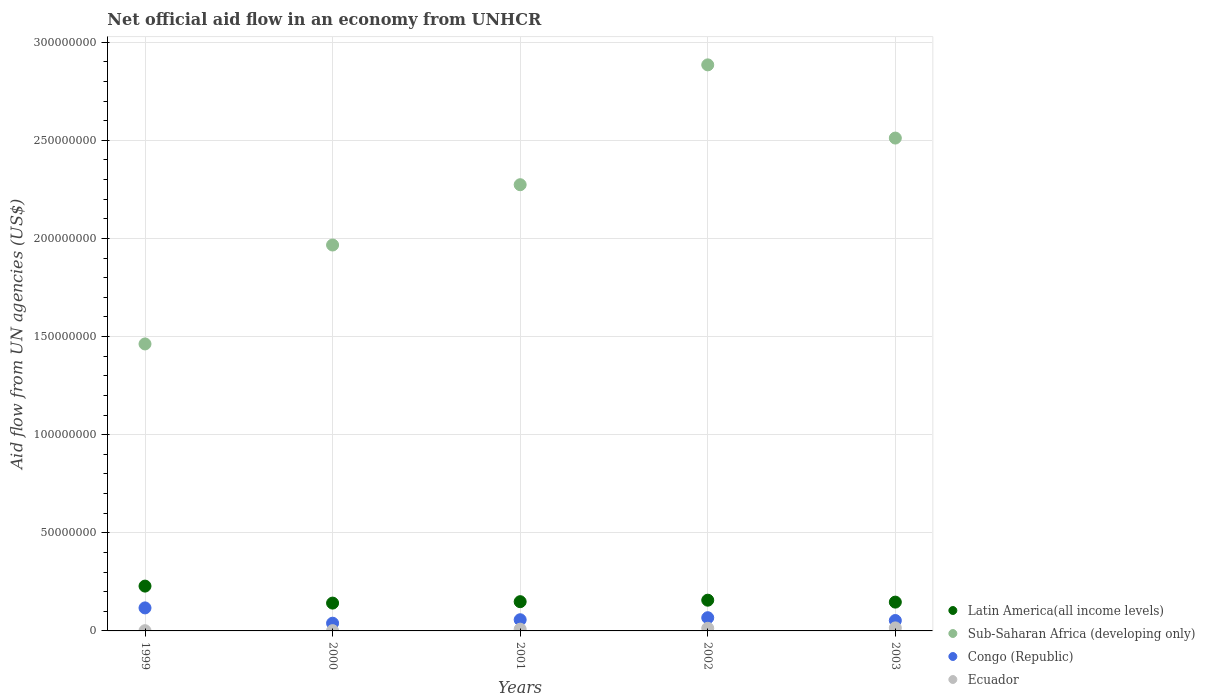How many different coloured dotlines are there?
Your answer should be compact. 4. Is the number of dotlines equal to the number of legend labels?
Keep it short and to the point. Yes. What is the net official aid flow in Congo (Republic) in 2000?
Offer a terse response. 3.93e+06. Across all years, what is the maximum net official aid flow in Latin America(all income levels)?
Offer a terse response. 2.28e+07. Across all years, what is the minimum net official aid flow in Sub-Saharan Africa (developing only)?
Provide a short and direct response. 1.46e+08. In which year was the net official aid flow in Latin America(all income levels) maximum?
Keep it short and to the point. 1999. In which year was the net official aid flow in Sub-Saharan Africa (developing only) minimum?
Make the answer very short. 1999. What is the total net official aid flow in Latin America(all income levels) in the graph?
Ensure brevity in your answer.  8.23e+07. What is the difference between the net official aid flow in Sub-Saharan Africa (developing only) in 1999 and that in 2000?
Provide a succinct answer. -5.04e+07. What is the difference between the net official aid flow in Latin America(all income levels) in 1999 and the net official aid flow in Sub-Saharan Africa (developing only) in 2001?
Your answer should be very brief. -2.05e+08. What is the average net official aid flow in Latin America(all income levels) per year?
Offer a very short reply. 1.65e+07. In the year 2003, what is the difference between the net official aid flow in Congo (Republic) and net official aid flow in Latin America(all income levels)?
Provide a succinct answer. -9.38e+06. What is the ratio of the net official aid flow in Ecuador in 1999 to that in 2000?
Ensure brevity in your answer.  0.86. Is the difference between the net official aid flow in Congo (Republic) in 2002 and 2003 greater than the difference between the net official aid flow in Latin America(all income levels) in 2002 and 2003?
Ensure brevity in your answer.  Yes. What is the difference between the highest and the second highest net official aid flow in Latin America(all income levels)?
Provide a short and direct response. 7.18e+06. What is the difference between the highest and the lowest net official aid flow in Sub-Saharan Africa (developing only)?
Your response must be concise. 1.42e+08. In how many years, is the net official aid flow in Sub-Saharan Africa (developing only) greater than the average net official aid flow in Sub-Saharan Africa (developing only) taken over all years?
Ensure brevity in your answer.  3. Is the sum of the net official aid flow in Latin America(all income levels) in 1999 and 2003 greater than the maximum net official aid flow in Congo (Republic) across all years?
Make the answer very short. Yes. Does the net official aid flow in Sub-Saharan Africa (developing only) monotonically increase over the years?
Your response must be concise. No. Is the net official aid flow in Latin America(all income levels) strictly greater than the net official aid flow in Congo (Republic) over the years?
Offer a terse response. Yes. How many dotlines are there?
Offer a terse response. 4. How many years are there in the graph?
Keep it short and to the point. 5. What is the difference between two consecutive major ticks on the Y-axis?
Offer a terse response. 5.00e+07. Does the graph contain any zero values?
Offer a very short reply. No. Does the graph contain grids?
Provide a short and direct response. Yes. Where does the legend appear in the graph?
Offer a very short reply. Bottom right. How are the legend labels stacked?
Offer a very short reply. Vertical. What is the title of the graph?
Offer a terse response. Net official aid flow in an economy from UNHCR. Does "Paraguay" appear as one of the legend labels in the graph?
Ensure brevity in your answer.  No. What is the label or title of the Y-axis?
Your answer should be compact. Aid flow from UN agencies (US$). What is the Aid flow from UN agencies (US$) of Latin America(all income levels) in 1999?
Make the answer very short. 2.28e+07. What is the Aid flow from UN agencies (US$) in Sub-Saharan Africa (developing only) in 1999?
Provide a succinct answer. 1.46e+08. What is the Aid flow from UN agencies (US$) in Congo (Republic) in 1999?
Your response must be concise. 1.17e+07. What is the Aid flow from UN agencies (US$) of Ecuador in 1999?
Provide a succinct answer. 1.20e+05. What is the Aid flow from UN agencies (US$) of Latin America(all income levels) in 2000?
Your response must be concise. 1.42e+07. What is the Aid flow from UN agencies (US$) of Sub-Saharan Africa (developing only) in 2000?
Offer a very short reply. 1.97e+08. What is the Aid flow from UN agencies (US$) in Congo (Republic) in 2000?
Your answer should be compact. 3.93e+06. What is the Aid flow from UN agencies (US$) in Latin America(all income levels) in 2001?
Provide a short and direct response. 1.49e+07. What is the Aid flow from UN agencies (US$) of Sub-Saharan Africa (developing only) in 2001?
Provide a succinct answer. 2.27e+08. What is the Aid flow from UN agencies (US$) of Congo (Republic) in 2001?
Offer a terse response. 5.70e+06. What is the Aid flow from UN agencies (US$) in Latin America(all income levels) in 2002?
Provide a short and direct response. 1.57e+07. What is the Aid flow from UN agencies (US$) of Sub-Saharan Africa (developing only) in 2002?
Make the answer very short. 2.88e+08. What is the Aid flow from UN agencies (US$) of Congo (Republic) in 2002?
Give a very brief answer. 6.73e+06. What is the Aid flow from UN agencies (US$) in Ecuador in 2002?
Provide a succinct answer. 1.34e+06. What is the Aid flow from UN agencies (US$) of Latin America(all income levels) in 2003?
Make the answer very short. 1.47e+07. What is the Aid flow from UN agencies (US$) in Sub-Saharan Africa (developing only) in 2003?
Provide a succinct answer. 2.51e+08. What is the Aid flow from UN agencies (US$) in Congo (Republic) in 2003?
Your answer should be compact. 5.30e+06. What is the Aid flow from UN agencies (US$) in Ecuador in 2003?
Your answer should be compact. 1.54e+06. Across all years, what is the maximum Aid flow from UN agencies (US$) of Latin America(all income levels)?
Keep it short and to the point. 2.28e+07. Across all years, what is the maximum Aid flow from UN agencies (US$) in Sub-Saharan Africa (developing only)?
Offer a terse response. 2.88e+08. Across all years, what is the maximum Aid flow from UN agencies (US$) of Congo (Republic)?
Offer a terse response. 1.17e+07. Across all years, what is the maximum Aid flow from UN agencies (US$) in Ecuador?
Your answer should be very brief. 1.54e+06. Across all years, what is the minimum Aid flow from UN agencies (US$) in Latin America(all income levels)?
Provide a succinct answer. 1.42e+07. Across all years, what is the minimum Aid flow from UN agencies (US$) in Sub-Saharan Africa (developing only)?
Provide a succinct answer. 1.46e+08. Across all years, what is the minimum Aid flow from UN agencies (US$) in Congo (Republic)?
Ensure brevity in your answer.  3.93e+06. Across all years, what is the minimum Aid flow from UN agencies (US$) of Ecuador?
Give a very brief answer. 1.20e+05. What is the total Aid flow from UN agencies (US$) of Latin America(all income levels) in the graph?
Your answer should be very brief. 8.23e+07. What is the total Aid flow from UN agencies (US$) in Sub-Saharan Africa (developing only) in the graph?
Provide a succinct answer. 1.11e+09. What is the total Aid flow from UN agencies (US$) of Congo (Republic) in the graph?
Provide a short and direct response. 3.34e+07. What is the total Aid flow from UN agencies (US$) of Ecuador in the graph?
Your answer should be compact. 4.04e+06. What is the difference between the Aid flow from UN agencies (US$) of Latin America(all income levels) in 1999 and that in 2000?
Your answer should be very brief. 8.66e+06. What is the difference between the Aid flow from UN agencies (US$) in Sub-Saharan Africa (developing only) in 1999 and that in 2000?
Provide a succinct answer. -5.04e+07. What is the difference between the Aid flow from UN agencies (US$) in Congo (Republic) in 1999 and that in 2000?
Keep it short and to the point. 7.80e+06. What is the difference between the Aid flow from UN agencies (US$) of Latin America(all income levels) in 1999 and that in 2001?
Offer a terse response. 7.94e+06. What is the difference between the Aid flow from UN agencies (US$) in Sub-Saharan Africa (developing only) in 1999 and that in 2001?
Your answer should be compact. -8.11e+07. What is the difference between the Aid flow from UN agencies (US$) in Congo (Republic) in 1999 and that in 2001?
Offer a terse response. 6.03e+06. What is the difference between the Aid flow from UN agencies (US$) of Ecuador in 1999 and that in 2001?
Your answer should be compact. -7.80e+05. What is the difference between the Aid flow from UN agencies (US$) of Latin America(all income levels) in 1999 and that in 2002?
Offer a very short reply. 7.18e+06. What is the difference between the Aid flow from UN agencies (US$) of Sub-Saharan Africa (developing only) in 1999 and that in 2002?
Ensure brevity in your answer.  -1.42e+08. What is the difference between the Aid flow from UN agencies (US$) of Congo (Republic) in 1999 and that in 2002?
Your response must be concise. 5.00e+06. What is the difference between the Aid flow from UN agencies (US$) in Ecuador in 1999 and that in 2002?
Provide a short and direct response. -1.22e+06. What is the difference between the Aid flow from UN agencies (US$) in Latin America(all income levels) in 1999 and that in 2003?
Make the answer very short. 8.16e+06. What is the difference between the Aid flow from UN agencies (US$) in Sub-Saharan Africa (developing only) in 1999 and that in 2003?
Ensure brevity in your answer.  -1.05e+08. What is the difference between the Aid flow from UN agencies (US$) in Congo (Republic) in 1999 and that in 2003?
Make the answer very short. 6.43e+06. What is the difference between the Aid flow from UN agencies (US$) in Ecuador in 1999 and that in 2003?
Your answer should be very brief. -1.42e+06. What is the difference between the Aid flow from UN agencies (US$) in Latin America(all income levels) in 2000 and that in 2001?
Provide a short and direct response. -7.20e+05. What is the difference between the Aid flow from UN agencies (US$) of Sub-Saharan Africa (developing only) in 2000 and that in 2001?
Provide a short and direct response. -3.07e+07. What is the difference between the Aid flow from UN agencies (US$) in Congo (Republic) in 2000 and that in 2001?
Offer a very short reply. -1.77e+06. What is the difference between the Aid flow from UN agencies (US$) of Ecuador in 2000 and that in 2001?
Ensure brevity in your answer.  -7.60e+05. What is the difference between the Aid flow from UN agencies (US$) of Latin America(all income levels) in 2000 and that in 2002?
Provide a succinct answer. -1.48e+06. What is the difference between the Aid flow from UN agencies (US$) of Sub-Saharan Africa (developing only) in 2000 and that in 2002?
Provide a short and direct response. -9.18e+07. What is the difference between the Aid flow from UN agencies (US$) of Congo (Republic) in 2000 and that in 2002?
Offer a very short reply. -2.80e+06. What is the difference between the Aid flow from UN agencies (US$) of Ecuador in 2000 and that in 2002?
Your answer should be very brief. -1.20e+06. What is the difference between the Aid flow from UN agencies (US$) of Latin America(all income levels) in 2000 and that in 2003?
Provide a short and direct response. -5.00e+05. What is the difference between the Aid flow from UN agencies (US$) in Sub-Saharan Africa (developing only) in 2000 and that in 2003?
Make the answer very short. -5.45e+07. What is the difference between the Aid flow from UN agencies (US$) of Congo (Republic) in 2000 and that in 2003?
Provide a succinct answer. -1.37e+06. What is the difference between the Aid flow from UN agencies (US$) of Ecuador in 2000 and that in 2003?
Make the answer very short. -1.40e+06. What is the difference between the Aid flow from UN agencies (US$) in Latin America(all income levels) in 2001 and that in 2002?
Give a very brief answer. -7.60e+05. What is the difference between the Aid flow from UN agencies (US$) of Sub-Saharan Africa (developing only) in 2001 and that in 2002?
Make the answer very short. -6.11e+07. What is the difference between the Aid flow from UN agencies (US$) in Congo (Republic) in 2001 and that in 2002?
Your answer should be compact. -1.03e+06. What is the difference between the Aid flow from UN agencies (US$) of Ecuador in 2001 and that in 2002?
Your answer should be very brief. -4.40e+05. What is the difference between the Aid flow from UN agencies (US$) of Sub-Saharan Africa (developing only) in 2001 and that in 2003?
Provide a succinct answer. -2.38e+07. What is the difference between the Aid flow from UN agencies (US$) in Ecuador in 2001 and that in 2003?
Your response must be concise. -6.40e+05. What is the difference between the Aid flow from UN agencies (US$) in Latin America(all income levels) in 2002 and that in 2003?
Your answer should be compact. 9.80e+05. What is the difference between the Aid flow from UN agencies (US$) of Sub-Saharan Africa (developing only) in 2002 and that in 2003?
Offer a very short reply. 3.73e+07. What is the difference between the Aid flow from UN agencies (US$) of Congo (Republic) in 2002 and that in 2003?
Offer a terse response. 1.43e+06. What is the difference between the Aid flow from UN agencies (US$) of Ecuador in 2002 and that in 2003?
Keep it short and to the point. -2.00e+05. What is the difference between the Aid flow from UN agencies (US$) in Latin America(all income levels) in 1999 and the Aid flow from UN agencies (US$) in Sub-Saharan Africa (developing only) in 2000?
Your answer should be compact. -1.74e+08. What is the difference between the Aid flow from UN agencies (US$) of Latin America(all income levels) in 1999 and the Aid flow from UN agencies (US$) of Congo (Republic) in 2000?
Make the answer very short. 1.89e+07. What is the difference between the Aid flow from UN agencies (US$) in Latin America(all income levels) in 1999 and the Aid flow from UN agencies (US$) in Ecuador in 2000?
Offer a very short reply. 2.27e+07. What is the difference between the Aid flow from UN agencies (US$) in Sub-Saharan Africa (developing only) in 1999 and the Aid flow from UN agencies (US$) in Congo (Republic) in 2000?
Give a very brief answer. 1.42e+08. What is the difference between the Aid flow from UN agencies (US$) of Sub-Saharan Africa (developing only) in 1999 and the Aid flow from UN agencies (US$) of Ecuador in 2000?
Ensure brevity in your answer.  1.46e+08. What is the difference between the Aid flow from UN agencies (US$) in Congo (Republic) in 1999 and the Aid flow from UN agencies (US$) in Ecuador in 2000?
Keep it short and to the point. 1.16e+07. What is the difference between the Aid flow from UN agencies (US$) of Latin America(all income levels) in 1999 and the Aid flow from UN agencies (US$) of Sub-Saharan Africa (developing only) in 2001?
Your answer should be compact. -2.05e+08. What is the difference between the Aid flow from UN agencies (US$) in Latin America(all income levels) in 1999 and the Aid flow from UN agencies (US$) in Congo (Republic) in 2001?
Your answer should be very brief. 1.71e+07. What is the difference between the Aid flow from UN agencies (US$) in Latin America(all income levels) in 1999 and the Aid flow from UN agencies (US$) in Ecuador in 2001?
Offer a terse response. 2.19e+07. What is the difference between the Aid flow from UN agencies (US$) in Sub-Saharan Africa (developing only) in 1999 and the Aid flow from UN agencies (US$) in Congo (Republic) in 2001?
Keep it short and to the point. 1.41e+08. What is the difference between the Aid flow from UN agencies (US$) of Sub-Saharan Africa (developing only) in 1999 and the Aid flow from UN agencies (US$) of Ecuador in 2001?
Make the answer very short. 1.45e+08. What is the difference between the Aid flow from UN agencies (US$) in Congo (Republic) in 1999 and the Aid flow from UN agencies (US$) in Ecuador in 2001?
Offer a very short reply. 1.08e+07. What is the difference between the Aid flow from UN agencies (US$) in Latin America(all income levels) in 1999 and the Aid flow from UN agencies (US$) in Sub-Saharan Africa (developing only) in 2002?
Your answer should be very brief. -2.66e+08. What is the difference between the Aid flow from UN agencies (US$) in Latin America(all income levels) in 1999 and the Aid flow from UN agencies (US$) in Congo (Republic) in 2002?
Provide a succinct answer. 1.61e+07. What is the difference between the Aid flow from UN agencies (US$) in Latin America(all income levels) in 1999 and the Aid flow from UN agencies (US$) in Ecuador in 2002?
Offer a terse response. 2.15e+07. What is the difference between the Aid flow from UN agencies (US$) in Sub-Saharan Africa (developing only) in 1999 and the Aid flow from UN agencies (US$) in Congo (Republic) in 2002?
Provide a short and direct response. 1.40e+08. What is the difference between the Aid flow from UN agencies (US$) in Sub-Saharan Africa (developing only) in 1999 and the Aid flow from UN agencies (US$) in Ecuador in 2002?
Ensure brevity in your answer.  1.45e+08. What is the difference between the Aid flow from UN agencies (US$) in Congo (Republic) in 1999 and the Aid flow from UN agencies (US$) in Ecuador in 2002?
Your answer should be compact. 1.04e+07. What is the difference between the Aid flow from UN agencies (US$) of Latin America(all income levels) in 1999 and the Aid flow from UN agencies (US$) of Sub-Saharan Africa (developing only) in 2003?
Offer a terse response. -2.28e+08. What is the difference between the Aid flow from UN agencies (US$) in Latin America(all income levels) in 1999 and the Aid flow from UN agencies (US$) in Congo (Republic) in 2003?
Your answer should be very brief. 1.75e+07. What is the difference between the Aid flow from UN agencies (US$) of Latin America(all income levels) in 1999 and the Aid flow from UN agencies (US$) of Ecuador in 2003?
Make the answer very short. 2.13e+07. What is the difference between the Aid flow from UN agencies (US$) in Sub-Saharan Africa (developing only) in 1999 and the Aid flow from UN agencies (US$) in Congo (Republic) in 2003?
Provide a short and direct response. 1.41e+08. What is the difference between the Aid flow from UN agencies (US$) of Sub-Saharan Africa (developing only) in 1999 and the Aid flow from UN agencies (US$) of Ecuador in 2003?
Make the answer very short. 1.45e+08. What is the difference between the Aid flow from UN agencies (US$) in Congo (Republic) in 1999 and the Aid flow from UN agencies (US$) in Ecuador in 2003?
Provide a succinct answer. 1.02e+07. What is the difference between the Aid flow from UN agencies (US$) of Latin America(all income levels) in 2000 and the Aid flow from UN agencies (US$) of Sub-Saharan Africa (developing only) in 2001?
Make the answer very short. -2.13e+08. What is the difference between the Aid flow from UN agencies (US$) of Latin America(all income levels) in 2000 and the Aid flow from UN agencies (US$) of Congo (Republic) in 2001?
Provide a succinct answer. 8.48e+06. What is the difference between the Aid flow from UN agencies (US$) in Latin America(all income levels) in 2000 and the Aid flow from UN agencies (US$) in Ecuador in 2001?
Provide a succinct answer. 1.33e+07. What is the difference between the Aid flow from UN agencies (US$) in Sub-Saharan Africa (developing only) in 2000 and the Aid flow from UN agencies (US$) in Congo (Republic) in 2001?
Your answer should be compact. 1.91e+08. What is the difference between the Aid flow from UN agencies (US$) of Sub-Saharan Africa (developing only) in 2000 and the Aid flow from UN agencies (US$) of Ecuador in 2001?
Provide a short and direct response. 1.96e+08. What is the difference between the Aid flow from UN agencies (US$) of Congo (Republic) in 2000 and the Aid flow from UN agencies (US$) of Ecuador in 2001?
Your response must be concise. 3.03e+06. What is the difference between the Aid flow from UN agencies (US$) in Latin America(all income levels) in 2000 and the Aid flow from UN agencies (US$) in Sub-Saharan Africa (developing only) in 2002?
Your answer should be very brief. -2.74e+08. What is the difference between the Aid flow from UN agencies (US$) in Latin America(all income levels) in 2000 and the Aid flow from UN agencies (US$) in Congo (Republic) in 2002?
Ensure brevity in your answer.  7.45e+06. What is the difference between the Aid flow from UN agencies (US$) in Latin America(all income levels) in 2000 and the Aid flow from UN agencies (US$) in Ecuador in 2002?
Your answer should be compact. 1.28e+07. What is the difference between the Aid flow from UN agencies (US$) in Sub-Saharan Africa (developing only) in 2000 and the Aid flow from UN agencies (US$) in Congo (Republic) in 2002?
Ensure brevity in your answer.  1.90e+08. What is the difference between the Aid flow from UN agencies (US$) in Sub-Saharan Africa (developing only) in 2000 and the Aid flow from UN agencies (US$) in Ecuador in 2002?
Provide a succinct answer. 1.95e+08. What is the difference between the Aid flow from UN agencies (US$) in Congo (Republic) in 2000 and the Aid flow from UN agencies (US$) in Ecuador in 2002?
Your answer should be compact. 2.59e+06. What is the difference between the Aid flow from UN agencies (US$) of Latin America(all income levels) in 2000 and the Aid flow from UN agencies (US$) of Sub-Saharan Africa (developing only) in 2003?
Give a very brief answer. -2.37e+08. What is the difference between the Aid flow from UN agencies (US$) of Latin America(all income levels) in 2000 and the Aid flow from UN agencies (US$) of Congo (Republic) in 2003?
Keep it short and to the point. 8.88e+06. What is the difference between the Aid flow from UN agencies (US$) in Latin America(all income levels) in 2000 and the Aid flow from UN agencies (US$) in Ecuador in 2003?
Provide a succinct answer. 1.26e+07. What is the difference between the Aid flow from UN agencies (US$) of Sub-Saharan Africa (developing only) in 2000 and the Aid flow from UN agencies (US$) of Congo (Republic) in 2003?
Ensure brevity in your answer.  1.91e+08. What is the difference between the Aid flow from UN agencies (US$) of Sub-Saharan Africa (developing only) in 2000 and the Aid flow from UN agencies (US$) of Ecuador in 2003?
Provide a short and direct response. 1.95e+08. What is the difference between the Aid flow from UN agencies (US$) in Congo (Republic) in 2000 and the Aid flow from UN agencies (US$) in Ecuador in 2003?
Your answer should be very brief. 2.39e+06. What is the difference between the Aid flow from UN agencies (US$) of Latin America(all income levels) in 2001 and the Aid flow from UN agencies (US$) of Sub-Saharan Africa (developing only) in 2002?
Your answer should be very brief. -2.74e+08. What is the difference between the Aid flow from UN agencies (US$) of Latin America(all income levels) in 2001 and the Aid flow from UN agencies (US$) of Congo (Republic) in 2002?
Your response must be concise. 8.17e+06. What is the difference between the Aid flow from UN agencies (US$) in Latin America(all income levels) in 2001 and the Aid flow from UN agencies (US$) in Ecuador in 2002?
Provide a succinct answer. 1.36e+07. What is the difference between the Aid flow from UN agencies (US$) in Sub-Saharan Africa (developing only) in 2001 and the Aid flow from UN agencies (US$) in Congo (Republic) in 2002?
Your response must be concise. 2.21e+08. What is the difference between the Aid flow from UN agencies (US$) in Sub-Saharan Africa (developing only) in 2001 and the Aid flow from UN agencies (US$) in Ecuador in 2002?
Keep it short and to the point. 2.26e+08. What is the difference between the Aid flow from UN agencies (US$) in Congo (Republic) in 2001 and the Aid flow from UN agencies (US$) in Ecuador in 2002?
Your answer should be compact. 4.36e+06. What is the difference between the Aid flow from UN agencies (US$) in Latin America(all income levels) in 2001 and the Aid flow from UN agencies (US$) in Sub-Saharan Africa (developing only) in 2003?
Your answer should be compact. -2.36e+08. What is the difference between the Aid flow from UN agencies (US$) of Latin America(all income levels) in 2001 and the Aid flow from UN agencies (US$) of Congo (Republic) in 2003?
Your answer should be compact. 9.60e+06. What is the difference between the Aid flow from UN agencies (US$) in Latin America(all income levels) in 2001 and the Aid flow from UN agencies (US$) in Ecuador in 2003?
Ensure brevity in your answer.  1.34e+07. What is the difference between the Aid flow from UN agencies (US$) of Sub-Saharan Africa (developing only) in 2001 and the Aid flow from UN agencies (US$) of Congo (Republic) in 2003?
Offer a terse response. 2.22e+08. What is the difference between the Aid flow from UN agencies (US$) in Sub-Saharan Africa (developing only) in 2001 and the Aid flow from UN agencies (US$) in Ecuador in 2003?
Provide a succinct answer. 2.26e+08. What is the difference between the Aid flow from UN agencies (US$) in Congo (Republic) in 2001 and the Aid flow from UN agencies (US$) in Ecuador in 2003?
Ensure brevity in your answer.  4.16e+06. What is the difference between the Aid flow from UN agencies (US$) of Latin America(all income levels) in 2002 and the Aid flow from UN agencies (US$) of Sub-Saharan Africa (developing only) in 2003?
Your answer should be very brief. -2.35e+08. What is the difference between the Aid flow from UN agencies (US$) in Latin America(all income levels) in 2002 and the Aid flow from UN agencies (US$) in Congo (Republic) in 2003?
Your answer should be compact. 1.04e+07. What is the difference between the Aid flow from UN agencies (US$) in Latin America(all income levels) in 2002 and the Aid flow from UN agencies (US$) in Ecuador in 2003?
Keep it short and to the point. 1.41e+07. What is the difference between the Aid flow from UN agencies (US$) of Sub-Saharan Africa (developing only) in 2002 and the Aid flow from UN agencies (US$) of Congo (Republic) in 2003?
Provide a succinct answer. 2.83e+08. What is the difference between the Aid flow from UN agencies (US$) of Sub-Saharan Africa (developing only) in 2002 and the Aid flow from UN agencies (US$) of Ecuador in 2003?
Offer a very short reply. 2.87e+08. What is the difference between the Aid flow from UN agencies (US$) of Congo (Republic) in 2002 and the Aid flow from UN agencies (US$) of Ecuador in 2003?
Your answer should be very brief. 5.19e+06. What is the average Aid flow from UN agencies (US$) of Latin America(all income levels) per year?
Ensure brevity in your answer.  1.65e+07. What is the average Aid flow from UN agencies (US$) of Sub-Saharan Africa (developing only) per year?
Provide a short and direct response. 2.22e+08. What is the average Aid flow from UN agencies (US$) in Congo (Republic) per year?
Offer a terse response. 6.68e+06. What is the average Aid flow from UN agencies (US$) in Ecuador per year?
Provide a succinct answer. 8.08e+05. In the year 1999, what is the difference between the Aid flow from UN agencies (US$) of Latin America(all income levels) and Aid flow from UN agencies (US$) of Sub-Saharan Africa (developing only)?
Give a very brief answer. -1.23e+08. In the year 1999, what is the difference between the Aid flow from UN agencies (US$) of Latin America(all income levels) and Aid flow from UN agencies (US$) of Congo (Republic)?
Your response must be concise. 1.11e+07. In the year 1999, what is the difference between the Aid flow from UN agencies (US$) of Latin America(all income levels) and Aid flow from UN agencies (US$) of Ecuador?
Provide a succinct answer. 2.27e+07. In the year 1999, what is the difference between the Aid flow from UN agencies (US$) in Sub-Saharan Africa (developing only) and Aid flow from UN agencies (US$) in Congo (Republic)?
Ensure brevity in your answer.  1.35e+08. In the year 1999, what is the difference between the Aid flow from UN agencies (US$) of Sub-Saharan Africa (developing only) and Aid flow from UN agencies (US$) of Ecuador?
Offer a terse response. 1.46e+08. In the year 1999, what is the difference between the Aid flow from UN agencies (US$) of Congo (Republic) and Aid flow from UN agencies (US$) of Ecuador?
Your answer should be very brief. 1.16e+07. In the year 2000, what is the difference between the Aid flow from UN agencies (US$) in Latin America(all income levels) and Aid flow from UN agencies (US$) in Sub-Saharan Africa (developing only)?
Your answer should be very brief. -1.82e+08. In the year 2000, what is the difference between the Aid flow from UN agencies (US$) in Latin America(all income levels) and Aid flow from UN agencies (US$) in Congo (Republic)?
Provide a succinct answer. 1.02e+07. In the year 2000, what is the difference between the Aid flow from UN agencies (US$) in Latin America(all income levels) and Aid flow from UN agencies (US$) in Ecuador?
Offer a very short reply. 1.40e+07. In the year 2000, what is the difference between the Aid flow from UN agencies (US$) of Sub-Saharan Africa (developing only) and Aid flow from UN agencies (US$) of Congo (Republic)?
Offer a terse response. 1.93e+08. In the year 2000, what is the difference between the Aid flow from UN agencies (US$) in Sub-Saharan Africa (developing only) and Aid flow from UN agencies (US$) in Ecuador?
Keep it short and to the point. 1.97e+08. In the year 2000, what is the difference between the Aid flow from UN agencies (US$) in Congo (Republic) and Aid flow from UN agencies (US$) in Ecuador?
Offer a terse response. 3.79e+06. In the year 2001, what is the difference between the Aid flow from UN agencies (US$) of Latin America(all income levels) and Aid flow from UN agencies (US$) of Sub-Saharan Africa (developing only)?
Your answer should be compact. -2.12e+08. In the year 2001, what is the difference between the Aid flow from UN agencies (US$) in Latin America(all income levels) and Aid flow from UN agencies (US$) in Congo (Republic)?
Keep it short and to the point. 9.20e+06. In the year 2001, what is the difference between the Aid flow from UN agencies (US$) of Latin America(all income levels) and Aid flow from UN agencies (US$) of Ecuador?
Offer a very short reply. 1.40e+07. In the year 2001, what is the difference between the Aid flow from UN agencies (US$) in Sub-Saharan Africa (developing only) and Aid flow from UN agencies (US$) in Congo (Republic)?
Provide a succinct answer. 2.22e+08. In the year 2001, what is the difference between the Aid flow from UN agencies (US$) in Sub-Saharan Africa (developing only) and Aid flow from UN agencies (US$) in Ecuador?
Provide a short and direct response. 2.26e+08. In the year 2001, what is the difference between the Aid flow from UN agencies (US$) of Congo (Republic) and Aid flow from UN agencies (US$) of Ecuador?
Provide a short and direct response. 4.80e+06. In the year 2002, what is the difference between the Aid flow from UN agencies (US$) of Latin America(all income levels) and Aid flow from UN agencies (US$) of Sub-Saharan Africa (developing only)?
Provide a short and direct response. -2.73e+08. In the year 2002, what is the difference between the Aid flow from UN agencies (US$) of Latin America(all income levels) and Aid flow from UN agencies (US$) of Congo (Republic)?
Your response must be concise. 8.93e+06. In the year 2002, what is the difference between the Aid flow from UN agencies (US$) of Latin America(all income levels) and Aid flow from UN agencies (US$) of Ecuador?
Provide a short and direct response. 1.43e+07. In the year 2002, what is the difference between the Aid flow from UN agencies (US$) of Sub-Saharan Africa (developing only) and Aid flow from UN agencies (US$) of Congo (Republic)?
Your answer should be very brief. 2.82e+08. In the year 2002, what is the difference between the Aid flow from UN agencies (US$) in Sub-Saharan Africa (developing only) and Aid flow from UN agencies (US$) in Ecuador?
Keep it short and to the point. 2.87e+08. In the year 2002, what is the difference between the Aid flow from UN agencies (US$) in Congo (Republic) and Aid flow from UN agencies (US$) in Ecuador?
Your answer should be compact. 5.39e+06. In the year 2003, what is the difference between the Aid flow from UN agencies (US$) of Latin America(all income levels) and Aid flow from UN agencies (US$) of Sub-Saharan Africa (developing only)?
Give a very brief answer. -2.36e+08. In the year 2003, what is the difference between the Aid flow from UN agencies (US$) in Latin America(all income levels) and Aid flow from UN agencies (US$) in Congo (Republic)?
Keep it short and to the point. 9.38e+06. In the year 2003, what is the difference between the Aid flow from UN agencies (US$) of Latin America(all income levels) and Aid flow from UN agencies (US$) of Ecuador?
Your response must be concise. 1.31e+07. In the year 2003, what is the difference between the Aid flow from UN agencies (US$) of Sub-Saharan Africa (developing only) and Aid flow from UN agencies (US$) of Congo (Republic)?
Give a very brief answer. 2.46e+08. In the year 2003, what is the difference between the Aid flow from UN agencies (US$) of Sub-Saharan Africa (developing only) and Aid flow from UN agencies (US$) of Ecuador?
Provide a short and direct response. 2.50e+08. In the year 2003, what is the difference between the Aid flow from UN agencies (US$) of Congo (Republic) and Aid flow from UN agencies (US$) of Ecuador?
Offer a terse response. 3.76e+06. What is the ratio of the Aid flow from UN agencies (US$) of Latin America(all income levels) in 1999 to that in 2000?
Ensure brevity in your answer.  1.61. What is the ratio of the Aid flow from UN agencies (US$) in Sub-Saharan Africa (developing only) in 1999 to that in 2000?
Your response must be concise. 0.74. What is the ratio of the Aid flow from UN agencies (US$) of Congo (Republic) in 1999 to that in 2000?
Offer a terse response. 2.98. What is the ratio of the Aid flow from UN agencies (US$) in Ecuador in 1999 to that in 2000?
Ensure brevity in your answer.  0.86. What is the ratio of the Aid flow from UN agencies (US$) of Latin America(all income levels) in 1999 to that in 2001?
Ensure brevity in your answer.  1.53. What is the ratio of the Aid flow from UN agencies (US$) in Sub-Saharan Africa (developing only) in 1999 to that in 2001?
Give a very brief answer. 0.64. What is the ratio of the Aid flow from UN agencies (US$) of Congo (Republic) in 1999 to that in 2001?
Make the answer very short. 2.06. What is the ratio of the Aid flow from UN agencies (US$) in Ecuador in 1999 to that in 2001?
Your answer should be compact. 0.13. What is the ratio of the Aid flow from UN agencies (US$) of Latin America(all income levels) in 1999 to that in 2002?
Provide a short and direct response. 1.46. What is the ratio of the Aid flow from UN agencies (US$) in Sub-Saharan Africa (developing only) in 1999 to that in 2002?
Your response must be concise. 0.51. What is the ratio of the Aid flow from UN agencies (US$) of Congo (Republic) in 1999 to that in 2002?
Offer a very short reply. 1.74. What is the ratio of the Aid flow from UN agencies (US$) of Ecuador in 1999 to that in 2002?
Give a very brief answer. 0.09. What is the ratio of the Aid flow from UN agencies (US$) of Latin America(all income levels) in 1999 to that in 2003?
Provide a succinct answer. 1.56. What is the ratio of the Aid flow from UN agencies (US$) of Sub-Saharan Africa (developing only) in 1999 to that in 2003?
Offer a terse response. 0.58. What is the ratio of the Aid flow from UN agencies (US$) of Congo (Republic) in 1999 to that in 2003?
Give a very brief answer. 2.21. What is the ratio of the Aid flow from UN agencies (US$) in Ecuador in 1999 to that in 2003?
Make the answer very short. 0.08. What is the ratio of the Aid flow from UN agencies (US$) in Latin America(all income levels) in 2000 to that in 2001?
Ensure brevity in your answer.  0.95. What is the ratio of the Aid flow from UN agencies (US$) in Sub-Saharan Africa (developing only) in 2000 to that in 2001?
Your response must be concise. 0.86. What is the ratio of the Aid flow from UN agencies (US$) in Congo (Republic) in 2000 to that in 2001?
Keep it short and to the point. 0.69. What is the ratio of the Aid flow from UN agencies (US$) of Ecuador in 2000 to that in 2001?
Make the answer very short. 0.16. What is the ratio of the Aid flow from UN agencies (US$) of Latin America(all income levels) in 2000 to that in 2002?
Keep it short and to the point. 0.91. What is the ratio of the Aid flow from UN agencies (US$) of Sub-Saharan Africa (developing only) in 2000 to that in 2002?
Make the answer very short. 0.68. What is the ratio of the Aid flow from UN agencies (US$) in Congo (Republic) in 2000 to that in 2002?
Your answer should be compact. 0.58. What is the ratio of the Aid flow from UN agencies (US$) of Ecuador in 2000 to that in 2002?
Provide a short and direct response. 0.1. What is the ratio of the Aid flow from UN agencies (US$) in Latin America(all income levels) in 2000 to that in 2003?
Your response must be concise. 0.97. What is the ratio of the Aid flow from UN agencies (US$) in Sub-Saharan Africa (developing only) in 2000 to that in 2003?
Provide a succinct answer. 0.78. What is the ratio of the Aid flow from UN agencies (US$) in Congo (Republic) in 2000 to that in 2003?
Ensure brevity in your answer.  0.74. What is the ratio of the Aid flow from UN agencies (US$) of Ecuador in 2000 to that in 2003?
Offer a terse response. 0.09. What is the ratio of the Aid flow from UN agencies (US$) in Latin America(all income levels) in 2001 to that in 2002?
Give a very brief answer. 0.95. What is the ratio of the Aid flow from UN agencies (US$) in Sub-Saharan Africa (developing only) in 2001 to that in 2002?
Provide a succinct answer. 0.79. What is the ratio of the Aid flow from UN agencies (US$) of Congo (Republic) in 2001 to that in 2002?
Offer a very short reply. 0.85. What is the ratio of the Aid flow from UN agencies (US$) in Ecuador in 2001 to that in 2002?
Your answer should be compact. 0.67. What is the ratio of the Aid flow from UN agencies (US$) in Latin America(all income levels) in 2001 to that in 2003?
Ensure brevity in your answer.  1.01. What is the ratio of the Aid flow from UN agencies (US$) in Sub-Saharan Africa (developing only) in 2001 to that in 2003?
Provide a succinct answer. 0.91. What is the ratio of the Aid flow from UN agencies (US$) of Congo (Republic) in 2001 to that in 2003?
Your answer should be very brief. 1.08. What is the ratio of the Aid flow from UN agencies (US$) in Ecuador in 2001 to that in 2003?
Your response must be concise. 0.58. What is the ratio of the Aid flow from UN agencies (US$) of Latin America(all income levels) in 2002 to that in 2003?
Offer a very short reply. 1.07. What is the ratio of the Aid flow from UN agencies (US$) of Sub-Saharan Africa (developing only) in 2002 to that in 2003?
Keep it short and to the point. 1.15. What is the ratio of the Aid flow from UN agencies (US$) of Congo (Republic) in 2002 to that in 2003?
Give a very brief answer. 1.27. What is the ratio of the Aid flow from UN agencies (US$) in Ecuador in 2002 to that in 2003?
Your answer should be compact. 0.87. What is the difference between the highest and the second highest Aid flow from UN agencies (US$) of Latin America(all income levels)?
Your answer should be compact. 7.18e+06. What is the difference between the highest and the second highest Aid flow from UN agencies (US$) of Sub-Saharan Africa (developing only)?
Ensure brevity in your answer.  3.73e+07. What is the difference between the highest and the second highest Aid flow from UN agencies (US$) of Ecuador?
Your response must be concise. 2.00e+05. What is the difference between the highest and the lowest Aid flow from UN agencies (US$) of Latin America(all income levels)?
Your answer should be very brief. 8.66e+06. What is the difference between the highest and the lowest Aid flow from UN agencies (US$) in Sub-Saharan Africa (developing only)?
Give a very brief answer. 1.42e+08. What is the difference between the highest and the lowest Aid flow from UN agencies (US$) in Congo (Republic)?
Make the answer very short. 7.80e+06. What is the difference between the highest and the lowest Aid flow from UN agencies (US$) in Ecuador?
Your response must be concise. 1.42e+06. 